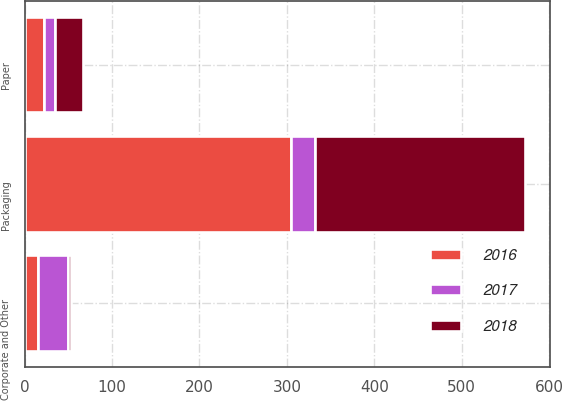Convert chart. <chart><loc_0><loc_0><loc_500><loc_500><stacked_bar_chart><ecel><fcel>Packaging<fcel>Paper<fcel>Corporate and Other<nl><fcel>2017<fcel>27.1<fcel>12.6<fcel>34.8<nl><fcel>2016<fcel>305.1<fcel>22.6<fcel>15.3<nl><fcel>2018<fcel>239.9<fcel>31.6<fcel>2.8<nl></chart> 